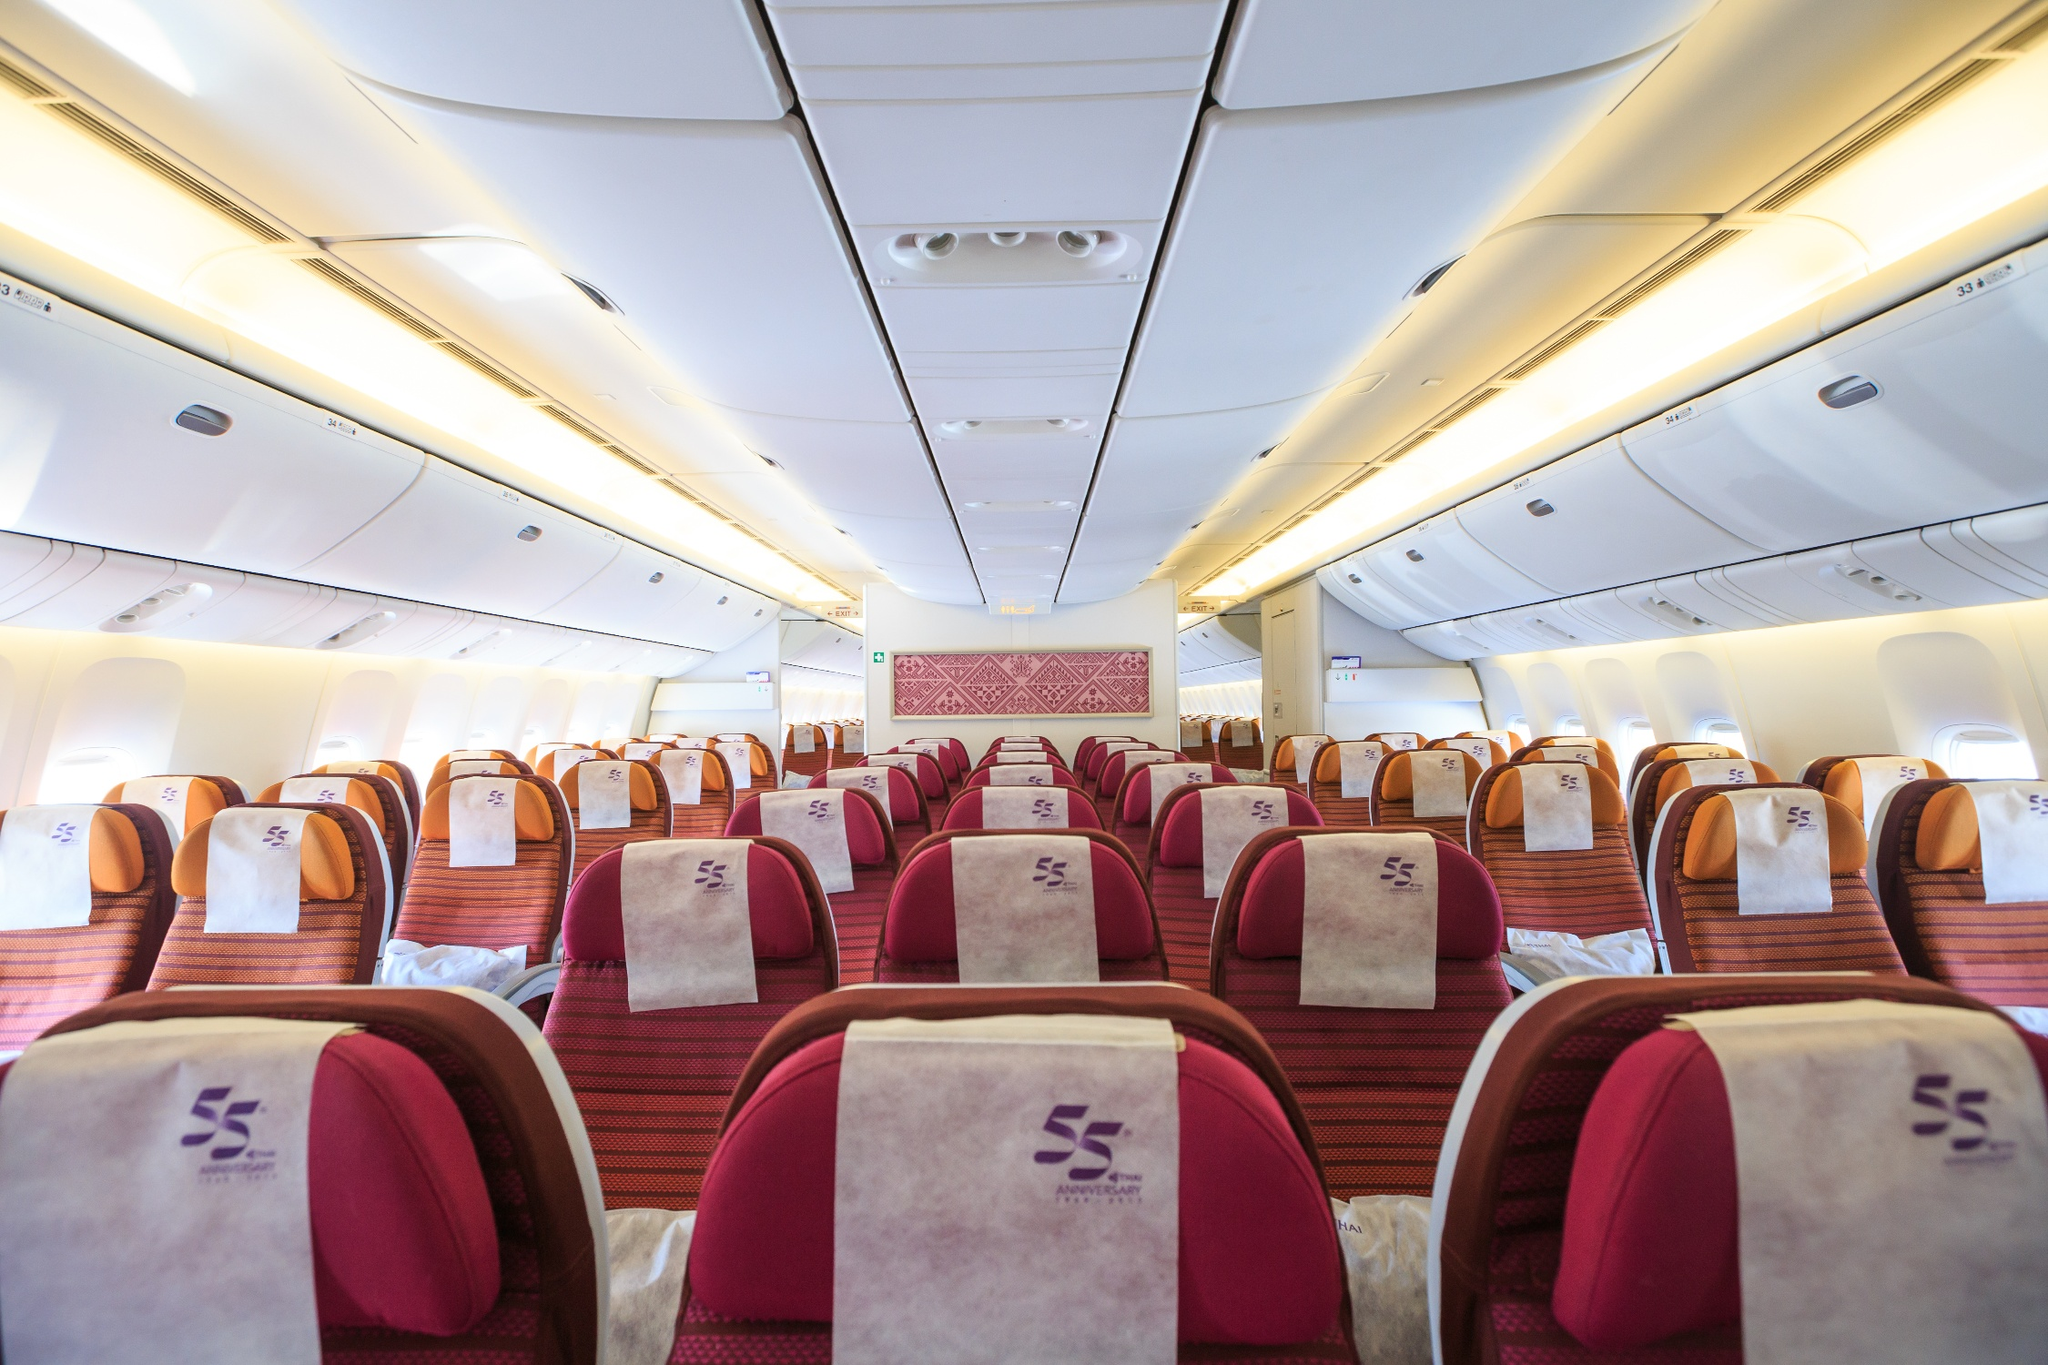What do you see happening in this image? This image vividly displays the interior of a commercial airliner, captured from a rear perspective. The cabin is outfitted with rows of seats in a luxurious 2-3-2 arrangement, presented in a rich, deep red tone with contrasting white headrests adorned with a purple logo resembling a stylized 'S'. The overhead compartments and walls, tinted in light beige, complement the cozy yet spacious atmosphere. Key design elements like the intricate pink pattern on the cabin's front partition reflect cultural or airline-specific aesthetics, hinting at a unique travel experience. Although the description mentioned a 'landmark information SA_14900,' it doesn't relate to visible features in the image. 